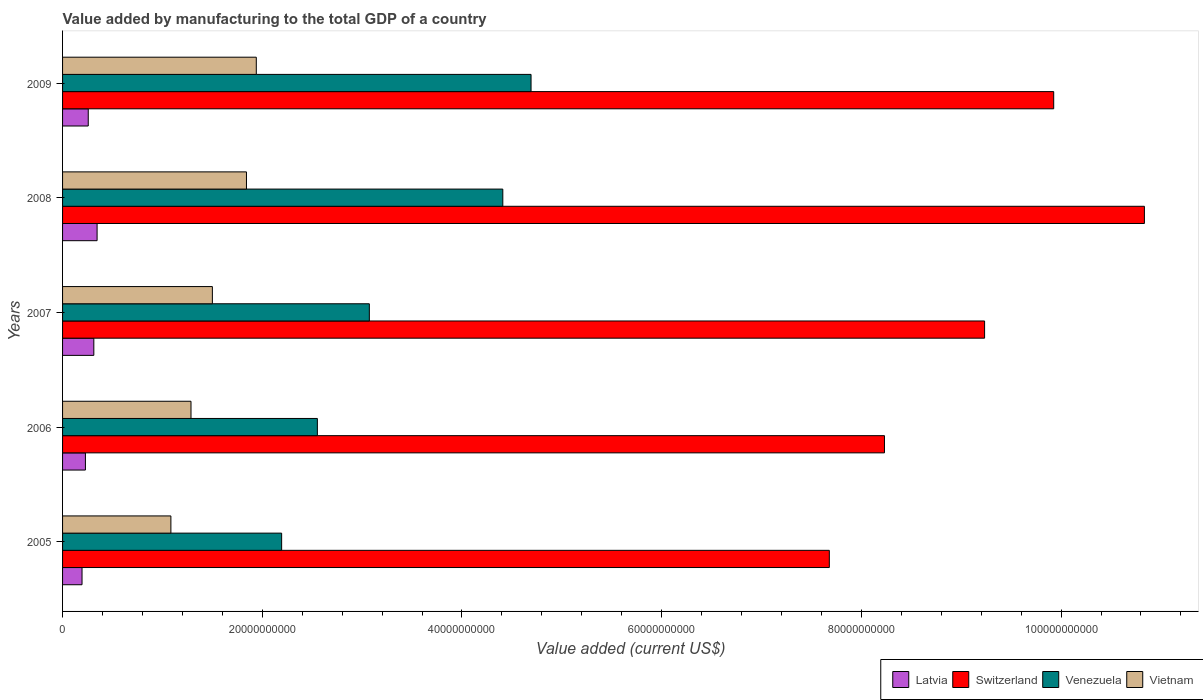Are the number of bars per tick equal to the number of legend labels?
Provide a short and direct response. Yes. How many bars are there on the 4th tick from the bottom?
Make the answer very short. 4. What is the label of the 4th group of bars from the top?
Provide a short and direct response. 2006. In how many cases, is the number of bars for a given year not equal to the number of legend labels?
Ensure brevity in your answer.  0. What is the value added by manufacturing to the total GDP in Switzerland in 2005?
Keep it short and to the point. 7.68e+1. Across all years, what is the maximum value added by manufacturing to the total GDP in Latvia?
Give a very brief answer. 3.46e+09. Across all years, what is the minimum value added by manufacturing to the total GDP in Switzerland?
Provide a succinct answer. 7.68e+1. In which year was the value added by manufacturing to the total GDP in Switzerland minimum?
Your answer should be very brief. 2005. What is the total value added by manufacturing to the total GDP in Venezuela in the graph?
Offer a terse response. 1.69e+11. What is the difference between the value added by manufacturing to the total GDP in Latvia in 2007 and that in 2008?
Your answer should be compact. -3.26e+08. What is the difference between the value added by manufacturing to the total GDP in Switzerland in 2005 and the value added by manufacturing to the total GDP in Vietnam in 2009?
Your answer should be compact. 5.74e+1. What is the average value added by manufacturing to the total GDP in Venezuela per year?
Offer a very short reply. 3.38e+1. In the year 2006, what is the difference between the value added by manufacturing to the total GDP in Latvia and value added by manufacturing to the total GDP in Venezuela?
Offer a very short reply. -2.32e+1. What is the ratio of the value added by manufacturing to the total GDP in Switzerland in 2007 to that in 2009?
Offer a terse response. 0.93. Is the value added by manufacturing to the total GDP in Switzerland in 2008 less than that in 2009?
Your answer should be very brief. No. Is the difference between the value added by manufacturing to the total GDP in Latvia in 2006 and 2008 greater than the difference between the value added by manufacturing to the total GDP in Venezuela in 2006 and 2008?
Offer a very short reply. Yes. What is the difference between the highest and the second highest value added by manufacturing to the total GDP in Vietnam?
Make the answer very short. 9.84e+08. What is the difference between the highest and the lowest value added by manufacturing to the total GDP in Latvia?
Keep it short and to the point. 1.51e+09. Is it the case that in every year, the sum of the value added by manufacturing to the total GDP in Vietnam and value added by manufacturing to the total GDP in Switzerland is greater than the sum of value added by manufacturing to the total GDP in Venezuela and value added by manufacturing to the total GDP in Latvia?
Provide a short and direct response. Yes. What does the 1st bar from the top in 2009 represents?
Your answer should be very brief. Vietnam. What does the 1st bar from the bottom in 2007 represents?
Provide a succinct answer. Latvia. Are all the bars in the graph horizontal?
Your answer should be compact. Yes. How many years are there in the graph?
Ensure brevity in your answer.  5. What is the difference between two consecutive major ticks on the X-axis?
Provide a succinct answer. 2.00e+1. Are the values on the major ticks of X-axis written in scientific E-notation?
Provide a succinct answer. No. Does the graph contain any zero values?
Provide a succinct answer. No. Does the graph contain grids?
Your answer should be very brief. No. How are the legend labels stacked?
Your answer should be very brief. Horizontal. What is the title of the graph?
Provide a succinct answer. Value added by manufacturing to the total GDP of a country. What is the label or title of the X-axis?
Provide a short and direct response. Value added (current US$). What is the label or title of the Y-axis?
Your answer should be very brief. Years. What is the Value added (current US$) of Latvia in 2005?
Make the answer very short. 1.95e+09. What is the Value added (current US$) of Switzerland in 2005?
Provide a succinct answer. 7.68e+1. What is the Value added (current US$) of Venezuela in 2005?
Your answer should be compact. 2.19e+1. What is the Value added (current US$) of Vietnam in 2005?
Offer a very short reply. 1.08e+1. What is the Value added (current US$) in Latvia in 2006?
Your response must be concise. 2.29e+09. What is the Value added (current US$) in Switzerland in 2006?
Your response must be concise. 8.23e+1. What is the Value added (current US$) of Venezuela in 2006?
Your answer should be compact. 2.55e+1. What is the Value added (current US$) in Vietnam in 2006?
Your response must be concise. 1.29e+1. What is the Value added (current US$) in Latvia in 2007?
Provide a succinct answer. 3.13e+09. What is the Value added (current US$) in Switzerland in 2007?
Your answer should be compact. 9.23e+1. What is the Value added (current US$) in Venezuela in 2007?
Give a very brief answer. 3.07e+1. What is the Value added (current US$) in Vietnam in 2007?
Provide a short and direct response. 1.50e+1. What is the Value added (current US$) in Latvia in 2008?
Ensure brevity in your answer.  3.46e+09. What is the Value added (current US$) in Switzerland in 2008?
Provide a succinct answer. 1.08e+11. What is the Value added (current US$) of Venezuela in 2008?
Ensure brevity in your answer.  4.41e+1. What is the Value added (current US$) in Vietnam in 2008?
Your answer should be very brief. 1.84e+1. What is the Value added (current US$) in Latvia in 2009?
Offer a very short reply. 2.57e+09. What is the Value added (current US$) in Switzerland in 2009?
Your answer should be very brief. 9.93e+1. What is the Value added (current US$) in Venezuela in 2009?
Your response must be concise. 4.69e+1. What is the Value added (current US$) in Vietnam in 2009?
Provide a short and direct response. 1.94e+1. Across all years, what is the maximum Value added (current US$) of Latvia?
Your response must be concise. 3.46e+09. Across all years, what is the maximum Value added (current US$) of Switzerland?
Your answer should be very brief. 1.08e+11. Across all years, what is the maximum Value added (current US$) in Venezuela?
Provide a short and direct response. 4.69e+1. Across all years, what is the maximum Value added (current US$) of Vietnam?
Your answer should be very brief. 1.94e+1. Across all years, what is the minimum Value added (current US$) in Latvia?
Provide a short and direct response. 1.95e+09. Across all years, what is the minimum Value added (current US$) in Switzerland?
Provide a short and direct response. 7.68e+1. Across all years, what is the minimum Value added (current US$) of Venezuela?
Your response must be concise. 2.19e+1. Across all years, what is the minimum Value added (current US$) of Vietnam?
Make the answer very short. 1.08e+1. What is the total Value added (current US$) in Latvia in the graph?
Give a very brief answer. 1.34e+1. What is the total Value added (current US$) in Switzerland in the graph?
Ensure brevity in your answer.  4.59e+11. What is the total Value added (current US$) in Venezuela in the graph?
Make the answer very short. 1.69e+11. What is the total Value added (current US$) in Vietnam in the graph?
Offer a very short reply. 7.65e+1. What is the difference between the Value added (current US$) of Latvia in 2005 and that in 2006?
Give a very brief answer. -3.40e+08. What is the difference between the Value added (current US$) of Switzerland in 2005 and that in 2006?
Offer a very short reply. -5.52e+09. What is the difference between the Value added (current US$) in Venezuela in 2005 and that in 2006?
Provide a short and direct response. -3.58e+09. What is the difference between the Value added (current US$) of Vietnam in 2005 and that in 2006?
Offer a very short reply. -2.01e+09. What is the difference between the Value added (current US$) in Latvia in 2005 and that in 2007?
Offer a very short reply. -1.18e+09. What is the difference between the Value added (current US$) in Switzerland in 2005 and that in 2007?
Keep it short and to the point. -1.56e+1. What is the difference between the Value added (current US$) of Venezuela in 2005 and that in 2007?
Your response must be concise. -8.78e+09. What is the difference between the Value added (current US$) of Vietnam in 2005 and that in 2007?
Keep it short and to the point. -4.15e+09. What is the difference between the Value added (current US$) of Latvia in 2005 and that in 2008?
Keep it short and to the point. -1.51e+09. What is the difference between the Value added (current US$) in Switzerland in 2005 and that in 2008?
Offer a very short reply. -3.16e+1. What is the difference between the Value added (current US$) in Venezuela in 2005 and that in 2008?
Make the answer very short. -2.22e+1. What is the difference between the Value added (current US$) of Vietnam in 2005 and that in 2008?
Your response must be concise. -7.57e+09. What is the difference between the Value added (current US$) of Latvia in 2005 and that in 2009?
Provide a succinct answer. -6.23e+08. What is the difference between the Value added (current US$) in Switzerland in 2005 and that in 2009?
Your answer should be compact. -2.25e+1. What is the difference between the Value added (current US$) of Venezuela in 2005 and that in 2009?
Your answer should be compact. -2.50e+1. What is the difference between the Value added (current US$) of Vietnam in 2005 and that in 2009?
Keep it short and to the point. -8.55e+09. What is the difference between the Value added (current US$) in Latvia in 2006 and that in 2007?
Your answer should be compact. -8.42e+08. What is the difference between the Value added (current US$) of Switzerland in 2006 and that in 2007?
Give a very brief answer. -1.00e+1. What is the difference between the Value added (current US$) of Venezuela in 2006 and that in 2007?
Your answer should be compact. -5.20e+09. What is the difference between the Value added (current US$) in Vietnam in 2006 and that in 2007?
Provide a short and direct response. -2.14e+09. What is the difference between the Value added (current US$) of Latvia in 2006 and that in 2008?
Give a very brief answer. -1.17e+09. What is the difference between the Value added (current US$) of Switzerland in 2006 and that in 2008?
Offer a terse response. -2.60e+1. What is the difference between the Value added (current US$) in Venezuela in 2006 and that in 2008?
Provide a succinct answer. -1.86e+1. What is the difference between the Value added (current US$) of Vietnam in 2006 and that in 2008?
Your response must be concise. -5.55e+09. What is the difference between the Value added (current US$) in Latvia in 2006 and that in 2009?
Keep it short and to the point. -2.83e+08. What is the difference between the Value added (current US$) of Switzerland in 2006 and that in 2009?
Offer a terse response. -1.69e+1. What is the difference between the Value added (current US$) in Venezuela in 2006 and that in 2009?
Give a very brief answer. -2.14e+1. What is the difference between the Value added (current US$) of Vietnam in 2006 and that in 2009?
Your answer should be very brief. -6.54e+09. What is the difference between the Value added (current US$) of Latvia in 2007 and that in 2008?
Offer a very short reply. -3.26e+08. What is the difference between the Value added (current US$) in Switzerland in 2007 and that in 2008?
Keep it short and to the point. -1.60e+1. What is the difference between the Value added (current US$) of Venezuela in 2007 and that in 2008?
Make the answer very short. -1.34e+1. What is the difference between the Value added (current US$) of Vietnam in 2007 and that in 2008?
Provide a succinct answer. -3.41e+09. What is the difference between the Value added (current US$) of Latvia in 2007 and that in 2009?
Provide a short and direct response. 5.58e+08. What is the difference between the Value added (current US$) in Switzerland in 2007 and that in 2009?
Provide a short and direct response. -6.92e+09. What is the difference between the Value added (current US$) in Venezuela in 2007 and that in 2009?
Your answer should be very brief. -1.62e+1. What is the difference between the Value added (current US$) in Vietnam in 2007 and that in 2009?
Make the answer very short. -4.40e+09. What is the difference between the Value added (current US$) of Latvia in 2008 and that in 2009?
Offer a terse response. 8.85e+08. What is the difference between the Value added (current US$) in Switzerland in 2008 and that in 2009?
Keep it short and to the point. 9.08e+09. What is the difference between the Value added (current US$) in Venezuela in 2008 and that in 2009?
Ensure brevity in your answer.  -2.83e+09. What is the difference between the Value added (current US$) in Vietnam in 2008 and that in 2009?
Give a very brief answer. -9.84e+08. What is the difference between the Value added (current US$) in Latvia in 2005 and the Value added (current US$) in Switzerland in 2006?
Ensure brevity in your answer.  -8.04e+1. What is the difference between the Value added (current US$) in Latvia in 2005 and the Value added (current US$) in Venezuela in 2006?
Offer a terse response. -2.36e+1. What is the difference between the Value added (current US$) in Latvia in 2005 and the Value added (current US$) in Vietnam in 2006?
Make the answer very short. -1.09e+1. What is the difference between the Value added (current US$) of Switzerland in 2005 and the Value added (current US$) of Venezuela in 2006?
Your response must be concise. 5.13e+1. What is the difference between the Value added (current US$) of Switzerland in 2005 and the Value added (current US$) of Vietnam in 2006?
Give a very brief answer. 6.39e+1. What is the difference between the Value added (current US$) of Venezuela in 2005 and the Value added (current US$) of Vietnam in 2006?
Give a very brief answer. 9.08e+09. What is the difference between the Value added (current US$) in Latvia in 2005 and the Value added (current US$) in Switzerland in 2007?
Offer a very short reply. -9.04e+1. What is the difference between the Value added (current US$) of Latvia in 2005 and the Value added (current US$) of Venezuela in 2007?
Your answer should be very brief. -2.88e+1. What is the difference between the Value added (current US$) of Latvia in 2005 and the Value added (current US$) of Vietnam in 2007?
Your response must be concise. -1.31e+1. What is the difference between the Value added (current US$) in Switzerland in 2005 and the Value added (current US$) in Venezuela in 2007?
Offer a very short reply. 4.61e+1. What is the difference between the Value added (current US$) in Switzerland in 2005 and the Value added (current US$) in Vietnam in 2007?
Give a very brief answer. 6.18e+1. What is the difference between the Value added (current US$) of Venezuela in 2005 and the Value added (current US$) of Vietnam in 2007?
Offer a terse response. 6.94e+09. What is the difference between the Value added (current US$) of Latvia in 2005 and the Value added (current US$) of Switzerland in 2008?
Provide a succinct answer. -1.06e+11. What is the difference between the Value added (current US$) of Latvia in 2005 and the Value added (current US$) of Venezuela in 2008?
Offer a very short reply. -4.21e+1. What is the difference between the Value added (current US$) of Latvia in 2005 and the Value added (current US$) of Vietnam in 2008?
Provide a succinct answer. -1.65e+1. What is the difference between the Value added (current US$) in Switzerland in 2005 and the Value added (current US$) in Venezuela in 2008?
Your response must be concise. 3.27e+1. What is the difference between the Value added (current US$) in Switzerland in 2005 and the Value added (current US$) in Vietnam in 2008?
Offer a terse response. 5.84e+1. What is the difference between the Value added (current US$) of Venezuela in 2005 and the Value added (current US$) of Vietnam in 2008?
Offer a very short reply. 3.52e+09. What is the difference between the Value added (current US$) in Latvia in 2005 and the Value added (current US$) in Switzerland in 2009?
Provide a succinct answer. -9.73e+1. What is the difference between the Value added (current US$) in Latvia in 2005 and the Value added (current US$) in Venezuela in 2009?
Provide a succinct answer. -4.50e+1. What is the difference between the Value added (current US$) in Latvia in 2005 and the Value added (current US$) in Vietnam in 2009?
Provide a short and direct response. -1.75e+1. What is the difference between the Value added (current US$) of Switzerland in 2005 and the Value added (current US$) of Venezuela in 2009?
Give a very brief answer. 2.99e+1. What is the difference between the Value added (current US$) in Switzerland in 2005 and the Value added (current US$) in Vietnam in 2009?
Make the answer very short. 5.74e+1. What is the difference between the Value added (current US$) of Venezuela in 2005 and the Value added (current US$) of Vietnam in 2009?
Make the answer very short. 2.54e+09. What is the difference between the Value added (current US$) of Latvia in 2006 and the Value added (current US$) of Switzerland in 2007?
Keep it short and to the point. -9.01e+1. What is the difference between the Value added (current US$) in Latvia in 2006 and the Value added (current US$) in Venezuela in 2007?
Give a very brief answer. -2.84e+1. What is the difference between the Value added (current US$) of Latvia in 2006 and the Value added (current US$) of Vietnam in 2007?
Offer a terse response. -1.27e+1. What is the difference between the Value added (current US$) in Switzerland in 2006 and the Value added (current US$) in Venezuela in 2007?
Ensure brevity in your answer.  5.16e+1. What is the difference between the Value added (current US$) in Switzerland in 2006 and the Value added (current US$) in Vietnam in 2007?
Provide a short and direct response. 6.73e+1. What is the difference between the Value added (current US$) of Venezuela in 2006 and the Value added (current US$) of Vietnam in 2007?
Provide a short and direct response. 1.05e+1. What is the difference between the Value added (current US$) of Latvia in 2006 and the Value added (current US$) of Switzerland in 2008?
Offer a very short reply. -1.06e+11. What is the difference between the Value added (current US$) in Latvia in 2006 and the Value added (current US$) in Venezuela in 2008?
Provide a succinct answer. -4.18e+1. What is the difference between the Value added (current US$) in Latvia in 2006 and the Value added (current US$) in Vietnam in 2008?
Your answer should be very brief. -1.61e+1. What is the difference between the Value added (current US$) of Switzerland in 2006 and the Value added (current US$) of Venezuela in 2008?
Provide a short and direct response. 3.82e+1. What is the difference between the Value added (current US$) of Switzerland in 2006 and the Value added (current US$) of Vietnam in 2008?
Your answer should be very brief. 6.39e+1. What is the difference between the Value added (current US$) of Venezuela in 2006 and the Value added (current US$) of Vietnam in 2008?
Ensure brevity in your answer.  7.10e+09. What is the difference between the Value added (current US$) in Latvia in 2006 and the Value added (current US$) in Switzerland in 2009?
Provide a succinct answer. -9.70e+1. What is the difference between the Value added (current US$) in Latvia in 2006 and the Value added (current US$) in Venezuela in 2009?
Provide a short and direct response. -4.46e+1. What is the difference between the Value added (current US$) in Latvia in 2006 and the Value added (current US$) in Vietnam in 2009?
Ensure brevity in your answer.  -1.71e+1. What is the difference between the Value added (current US$) in Switzerland in 2006 and the Value added (current US$) in Venezuela in 2009?
Offer a terse response. 3.54e+1. What is the difference between the Value added (current US$) in Switzerland in 2006 and the Value added (current US$) in Vietnam in 2009?
Give a very brief answer. 6.29e+1. What is the difference between the Value added (current US$) in Venezuela in 2006 and the Value added (current US$) in Vietnam in 2009?
Your answer should be compact. 6.12e+09. What is the difference between the Value added (current US$) in Latvia in 2007 and the Value added (current US$) in Switzerland in 2008?
Your answer should be very brief. -1.05e+11. What is the difference between the Value added (current US$) of Latvia in 2007 and the Value added (current US$) of Venezuela in 2008?
Offer a terse response. -4.10e+1. What is the difference between the Value added (current US$) in Latvia in 2007 and the Value added (current US$) in Vietnam in 2008?
Provide a short and direct response. -1.53e+1. What is the difference between the Value added (current US$) in Switzerland in 2007 and the Value added (current US$) in Venezuela in 2008?
Provide a succinct answer. 4.82e+1. What is the difference between the Value added (current US$) in Switzerland in 2007 and the Value added (current US$) in Vietnam in 2008?
Provide a short and direct response. 7.39e+1. What is the difference between the Value added (current US$) in Venezuela in 2007 and the Value added (current US$) in Vietnam in 2008?
Make the answer very short. 1.23e+1. What is the difference between the Value added (current US$) of Latvia in 2007 and the Value added (current US$) of Switzerland in 2009?
Provide a succinct answer. -9.61e+1. What is the difference between the Value added (current US$) of Latvia in 2007 and the Value added (current US$) of Venezuela in 2009?
Your answer should be very brief. -4.38e+1. What is the difference between the Value added (current US$) of Latvia in 2007 and the Value added (current US$) of Vietnam in 2009?
Give a very brief answer. -1.63e+1. What is the difference between the Value added (current US$) of Switzerland in 2007 and the Value added (current US$) of Venezuela in 2009?
Give a very brief answer. 4.54e+1. What is the difference between the Value added (current US$) of Switzerland in 2007 and the Value added (current US$) of Vietnam in 2009?
Provide a succinct answer. 7.29e+1. What is the difference between the Value added (current US$) in Venezuela in 2007 and the Value added (current US$) in Vietnam in 2009?
Provide a succinct answer. 1.13e+1. What is the difference between the Value added (current US$) in Latvia in 2008 and the Value added (current US$) in Switzerland in 2009?
Your answer should be very brief. -9.58e+1. What is the difference between the Value added (current US$) in Latvia in 2008 and the Value added (current US$) in Venezuela in 2009?
Your answer should be very brief. -4.35e+1. What is the difference between the Value added (current US$) in Latvia in 2008 and the Value added (current US$) in Vietnam in 2009?
Your answer should be very brief. -1.59e+1. What is the difference between the Value added (current US$) of Switzerland in 2008 and the Value added (current US$) of Venezuela in 2009?
Ensure brevity in your answer.  6.14e+1. What is the difference between the Value added (current US$) in Switzerland in 2008 and the Value added (current US$) in Vietnam in 2009?
Keep it short and to the point. 8.89e+1. What is the difference between the Value added (current US$) of Venezuela in 2008 and the Value added (current US$) of Vietnam in 2009?
Keep it short and to the point. 2.47e+1. What is the average Value added (current US$) of Latvia per year?
Make the answer very short. 2.68e+09. What is the average Value added (current US$) of Switzerland per year?
Give a very brief answer. 9.18e+1. What is the average Value added (current US$) in Venezuela per year?
Keep it short and to the point. 3.38e+1. What is the average Value added (current US$) in Vietnam per year?
Offer a very short reply. 1.53e+1. In the year 2005, what is the difference between the Value added (current US$) of Latvia and Value added (current US$) of Switzerland?
Keep it short and to the point. -7.48e+1. In the year 2005, what is the difference between the Value added (current US$) in Latvia and Value added (current US$) in Venezuela?
Your response must be concise. -2.00e+1. In the year 2005, what is the difference between the Value added (current US$) of Latvia and Value added (current US$) of Vietnam?
Your answer should be very brief. -8.90e+09. In the year 2005, what is the difference between the Value added (current US$) in Switzerland and Value added (current US$) in Venezuela?
Offer a terse response. 5.48e+1. In the year 2005, what is the difference between the Value added (current US$) in Switzerland and Value added (current US$) in Vietnam?
Keep it short and to the point. 6.59e+1. In the year 2005, what is the difference between the Value added (current US$) in Venezuela and Value added (current US$) in Vietnam?
Provide a succinct answer. 1.11e+1. In the year 2006, what is the difference between the Value added (current US$) in Latvia and Value added (current US$) in Switzerland?
Your answer should be compact. -8.00e+1. In the year 2006, what is the difference between the Value added (current US$) in Latvia and Value added (current US$) in Venezuela?
Provide a short and direct response. -2.32e+1. In the year 2006, what is the difference between the Value added (current US$) in Latvia and Value added (current US$) in Vietnam?
Make the answer very short. -1.06e+1. In the year 2006, what is the difference between the Value added (current US$) of Switzerland and Value added (current US$) of Venezuela?
Offer a terse response. 5.68e+1. In the year 2006, what is the difference between the Value added (current US$) of Switzerland and Value added (current US$) of Vietnam?
Provide a short and direct response. 6.95e+1. In the year 2006, what is the difference between the Value added (current US$) in Venezuela and Value added (current US$) in Vietnam?
Provide a succinct answer. 1.27e+1. In the year 2007, what is the difference between the Value added (current US$) in Latvia and Value added (current US$) in Switzerland?
Your response must be concise. -8.92e+1. In the year 2007, what is the difference between the Value added (current US$) in Latvia and Value added (current US$) in Venezuela?
Your answer should be compact. -2.76e+1. In the year 2007, what is the difference between the Value added (current US$) of Latvia and Value added (current US$) of Vietnam?
Make the answer very short. -1.19e+1. In the year 2007, what is the difference between the Value added (current US$) in Switzerland and Value added (current US$) in Venezuela?
Give a very brief answer. 6.16e+1. In the year 2007, what is the difference between the Value added (current US$) in Switzerland and Value added (current US$) in Vietnam?
Make the answer very short. 7.73e+1. In the year 2007, what is the difference between the Value added (current US$) in Venezuela and Value added (current US$) in Vietnam?
Your answer should be compact. 1.57e+1. In the year 2008, what is the difference between the Value added (current US$) of Latvia and Value added (current US$) of Switzerland?
Your answer should be compact. -1.05e+11. In the year 2008, what is the difference between the Value added (current US$) of Latvia and Value added (current US$) of Venezuela?
Make the answer very short. -4.06e+1. In the year 2008, what is the difference between the Value added (current US$) in Latvia and Value added (current US$) in Vietnam?
Give a very brief answer. -1.50e+1. In the year 2008, what is the difference between the Value added (current US$) of Switzerland and Value added (current US$) of Venezuela?
Offer a terse response. 6.43e+1. In the year 2008, what is the difference between the Value added (current US$) in Switzerland and Value added (current US$) in Vietnam?
Provide a short and direct response. 8.99e+1. In the year 2008, what is the difference between the Value added (current US$) of Venezuela and Value added (current US$) of Vietnam?
Your answer should be very brief. 2.57e+1. In the year 2009, what is the difference between the Value added (current US$) of Latvia and Value added (current US$) of Switzerland?
Offer a terse response. -9.67e+1. In the year 2009, what is the difference between the Value added (current US$) of Latvia and Value added (current US$) of Venezuela?
Your response must be concise. -4.43e+1. In the year 2009, what is the difference between the Value added (current US$) of Latvia and Value added (current US$) of Vietnam?
Offer a terse response. -1.68e+1. In the year 2009, what is the difference between the Value added (current US$) in Switzerland and Value added (current US$) in Venezuela?
Your response must be concise. 5.23e+1. In the year 2009, what is the difference between the Value added (current US$) of Switzerland and Value added (current US$) of Vietnam?
Ensure brevity in your answer.  7.99e+1. In the year 2009, what is the difference between the Value added (current US$) of Venezuela and Value added (current US$) of Vietnam?
Keep it short and to the point. 2.75e+1. What is the ratio of the Value added (current US$) in Latvia in 2005 to that in 2006?
Make the answer very short. 0.85. What is the ratio of the Value added (current US$) of Switzerland in 2005 to that in 2006?
Provide a succinct answer. 0.93. What is the ratio of the Value added (current US$) of Venezuela in 2005 to that in 2006?
Keep it short and to the point. 0.86. What is the ratio of the Value added (current US$) of Vietnam in 2005 to that in 2006?
Make the answer very short. 0.84. What is the ratio of the Value added (current US$) in Latvia in 2005 to that in 2007?
Offer a terse response. 0.62. What is the ratio of the Value added (current US$) in Switzerland in 2005 to that in 2007?
Provide a short and direct response. 0.83. What is the ratio of the Value added (current US$) of Venezuela in 2005 to that in 2007?
Keep it short and to the point. 0.71. What is the ratio of the Value added (current US$) in Vietnam in 2005 to that in 2007?
Make the answer very short. 0.72. What is the ratio of the Value added (current US$) in Latvia in 2005 to that in 2008?
Your response must be concise. 0.56. What is the ratio of the Value added (current US$) in Switzerland in 2005 to that in 2008?
Provide a succinct answer. 0.71. What is the ratio of the Value added (current US$) in Venezuela in 2005 to that in 2008?
Your answer should be very brief. 0.5. What is the ratio of the Value added (current US$) of Vietnam in 2005 to that in 2008?
Make the answer very short. 0.59. What is the ratio of the Value added (current US$) of Latvia in 2005 to that in 2009?
Give a very brief answer. 0.76. What is the ratio of the Value added (current US$) of Switzerland in 2005 to that in 2009?
Your answer should be compact. 0.77. What is the ratio of the Value added (current US$) in Venezuela in 2005 to that in 2009?
Your answer should be compact. 0.47. What is the ratio of the Value added (current US$) of Vietnam in 2005 to that in 2009?
Offer a very short reply. 0.56. What is the ratio of the Value added (current US$) in Latvia in 2006 to that in 2007?
Offer a very short reply. 0.73. What is the ratio of the Value added (current US$) of Switzerland in 2006 to that in 2007?
Make the answer very short. 0.89. What is the ratio of the Value added (current US$) of Venezuela in 2006 to that in 2007?
Offer a terse response. 0.83. What is the ratio of the Value added (current US$) in Vietnam in 2006 to that in 2007?
Ensure brevity in your answer.  0.86. What is the ratio of the Value added (current US$) of Latvia in 2006 to that in 2008?
Keep it short and to the point. 0.66. What is the ratio of the Value added (current US$) in Switzerland in 2006 to that in 2008?
Offer a very short reply. 0.76. What is the ratio of the Value added (current US$) in Venezuela in 2006 to that in 2008?
Provide a succinct answer. 0.58. What is the ratio of the Value added (current US$) of Vietnam in 2006 to that in 2008?
Make the answer very short. 0.7. What is the ratio of the Value added (current US$) in Latvia in 2006 to that in 2009?
Provide a short and direct response. 0.89. What is the ratio of the Value added (current US$) in Switzerland in 2006 to that in 2009?
Your response must be concise. 0.83. What is the ratio of the Value added (current US$) of Venezuela in 2006 to that in 2009?
Your response must be concise. 0.54. What is the ratio of the Value added (current US$) of Vietnam in 2006 to that in 2009?
Offer a terse response. 0.66. What is the ratio of the Value added (current US$) of Latvia in 2007 to that in 2008?
Offer a terse response. 0.91. What is the ratio of the Value added (current US$) of Switzerland in 2007 to that in 2008?
Ensure brevity in your answer.  0.85. What is the ratio of the Value added (current US$) in Venezuela in 2007 to that in 2008?
Your answer should be compact. 0.7. What is the ratio of the Value added (current US$) of Vietnam in 2007 to that in 2008?
Offer a terse response. 0.81. What is the ratio of the Value added (current US$) in Latvia in 2007 to that in 2009?
Provide a succinct answer. 1.22. What is the ratio of the Value added (current US$) in Switzerland in 2007 to that in 2009?
Offer a very short reply. 0.93. What is the ratio of the Value added (current US$) of Venezuela in 2007 to that in 2009?
Give a very brief answer. 0.65. What is the ratio of the Value added (current US$) in Vietnam in 2007 to that in 2009?
Give a very brief answer. 0.77. What is the ratio of the Value added (current US$) in Latvia in 2008 to that in 2009?
Offer a very short reply. 1.34. What is the ratio of the Value added (current US$) in Switzerland in 2008 to that in 2009?
Offer a very short reply. 1.09. What is the ratio of the Value added (current US$) of Venezuela in 2008 to that in 2009?
Your answer should be very brief. 0.94. What is the ratio of the Value added (current US$) in Vietnam in 2008 to that in 2009?
Your answer should be compact. 0.95. What is the difference between the highest and the second highest Value added (current US$) in Latvia?
Your answer should be very brief. 3.26e+08. What is the difference between the highest and the second highest Value added (current US$) in Switzerland?
Keep it short and to the point. 9.08e+09. What is the difference between the highest and the second highest Value added (current US$) in Venezuela?
Your answer should be very brief. 2.83e+09. What is the difference between the highest and the second highest Value added (current US$) of Vietnam?
Keep it short and to the point. 9.84e+08. What is the difference between the highest and the lowest Value added (current US$) of Latvia?
Ensure brevity in your answer.  1.51e+09. What is the difference between the highest and the lowest Value added (current US$) in Switzerland?
Your response must be concise. 3.16e+1. What is the difference between the highest and the lowest Value added (current US$) of Venezuela?
Provide a succinct answer. 2.50e+1. What is the difference between the highest and the lowest Value added (current US$) of Vietnam?
Provide a short and direct response. 8.55e+09. 